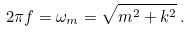<formula> <loc_0><loc_0><loc_500><loc_500>2 \pi f = \omega _ { m } = \sqrt { m ^ { 2 } + k ^ { 2 } } \, .</formula> 